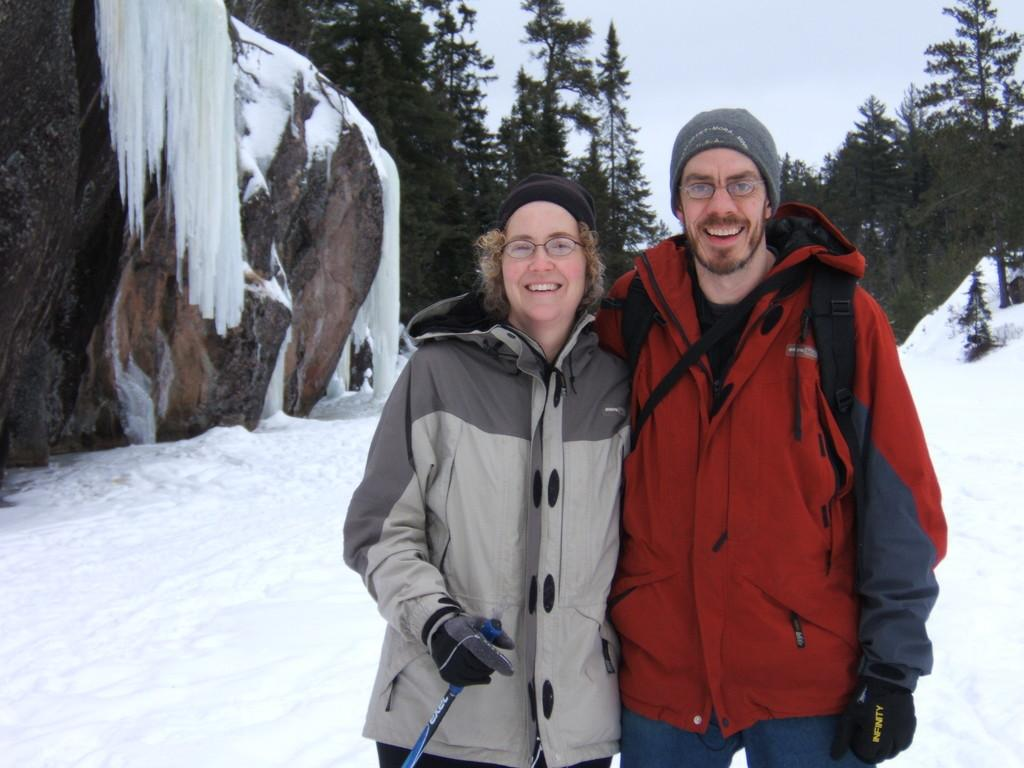How many people are in the image? There are two people in the image. What are the people doing in the image? Both people are standing and smiling. What clothing items are the people wearing? The people are wearing caps and gloves. What is one person holding in the image? One person is holding a stick. What type of weather is depicted in the image? There is snow visible in the image. What can be seen in the background of the image? In the background, there are rocks, trees, and the sky. What type of zipper can be seen on the person's jacket in the image? There is no zipper visible on the person's jacket in the image. Is the person's brother also present in the image? The provided facts do not mention any relationship between the two people in the image, so we cannot determine if one is the other's brother. 